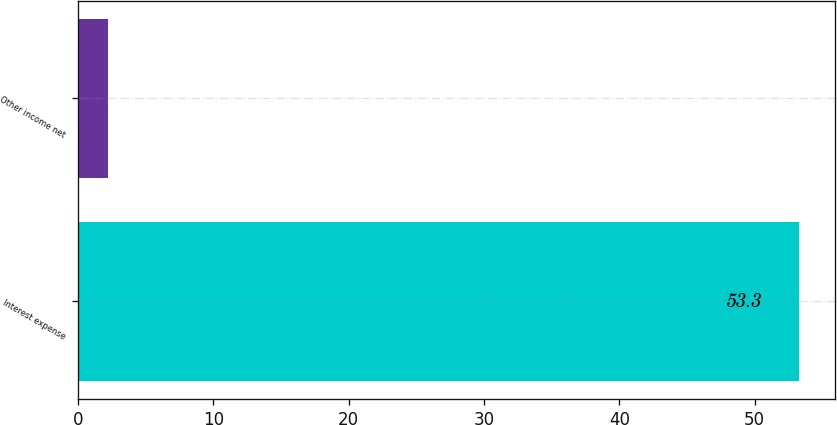Convert chart. <chart><loc_0><loc_0><loc_500><loc_500><bar_chart><fcel>Interest expense<fcel>Other income net<nl><fcel>53.3<fcel>2.2<nl></chart> 